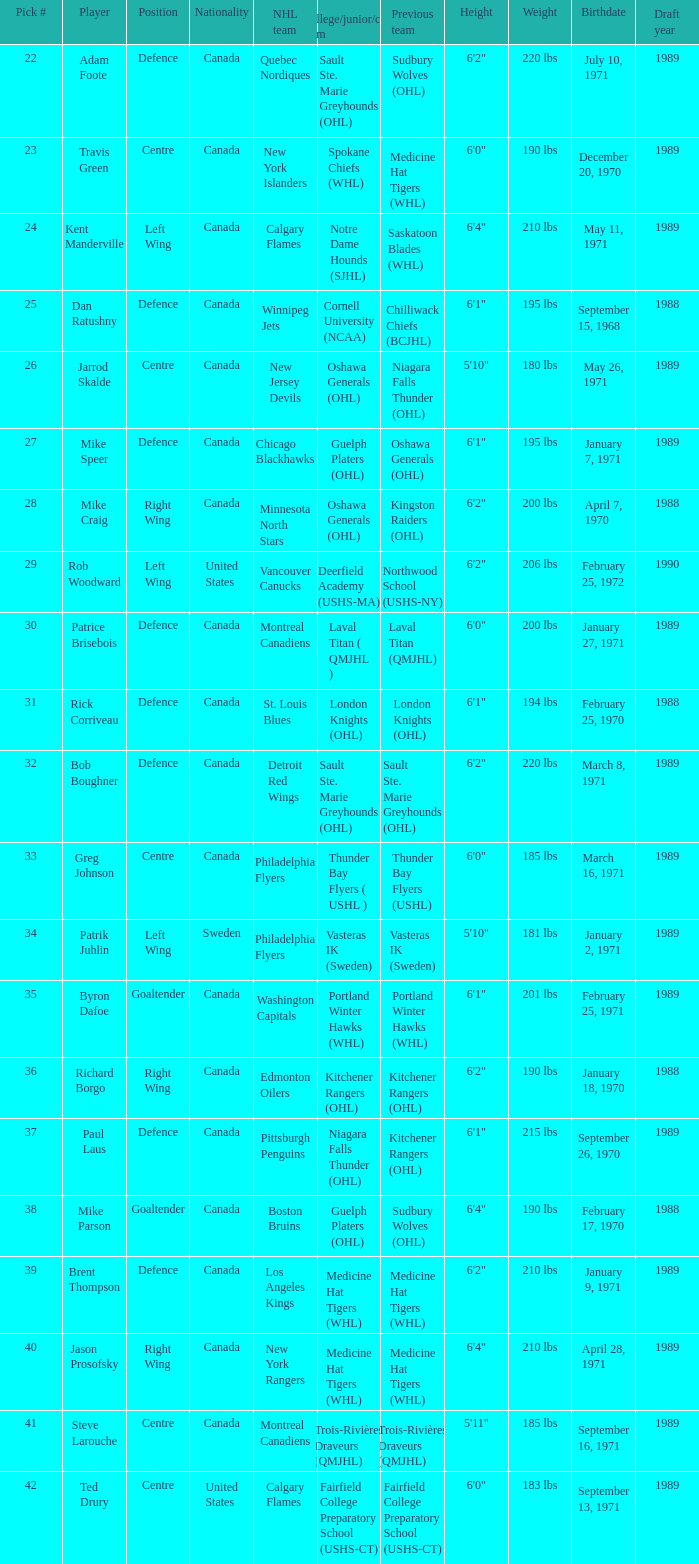What is the nationality of the draft pick player who plays centre position and is going to Calgary Flames? United States. 